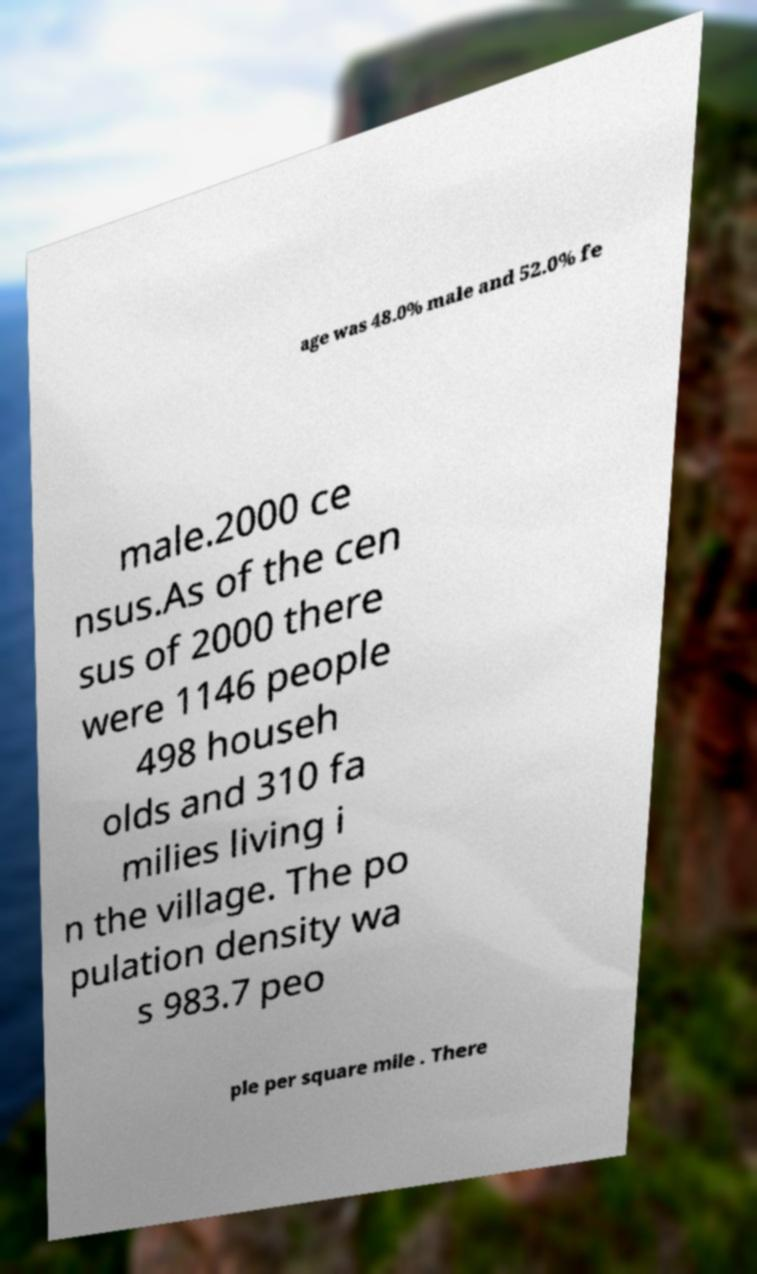Could you assist in decoding the text presented in this image and type it out clearly? age was 48.0% male and 52.0% fe male.2000 ce nsus.As of the cen sus of 2000 there were 1146 people 498 househ olds and 310 fa milies living i n the village. The po pulation density wa s 983.7 peo ple per square mile . There 